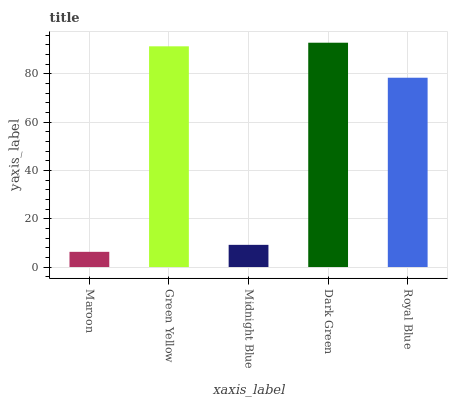Is Maroon the minimum?
Answer yes or no. Yes. Is Dark Green the maximum?
Answer yes or no. Yes. Is Green Yellow the minimum?
Answer yes or no. No. Is Green Yellow the maximum?
Answer yes or no. No. Is Green Yellow greater than Maroon?
Answer yes or no. Yes. Is Maroon less than Green Yellow?
Answer yes or no. Yes. Is Maroon greater than Green Yellow?
Answer yes or no. No. Is Green Yellow less than Maroon?
Answer yes or no. No. Is Royal Blue the high median?
Answer yes or no. Yes. Is Royal Blue the low median?
Answer yes or no. Yes. Is Green Yellow the high median?
Answer yes or no. No. Is Dark Green the low median?
Answer yes or no. No. 